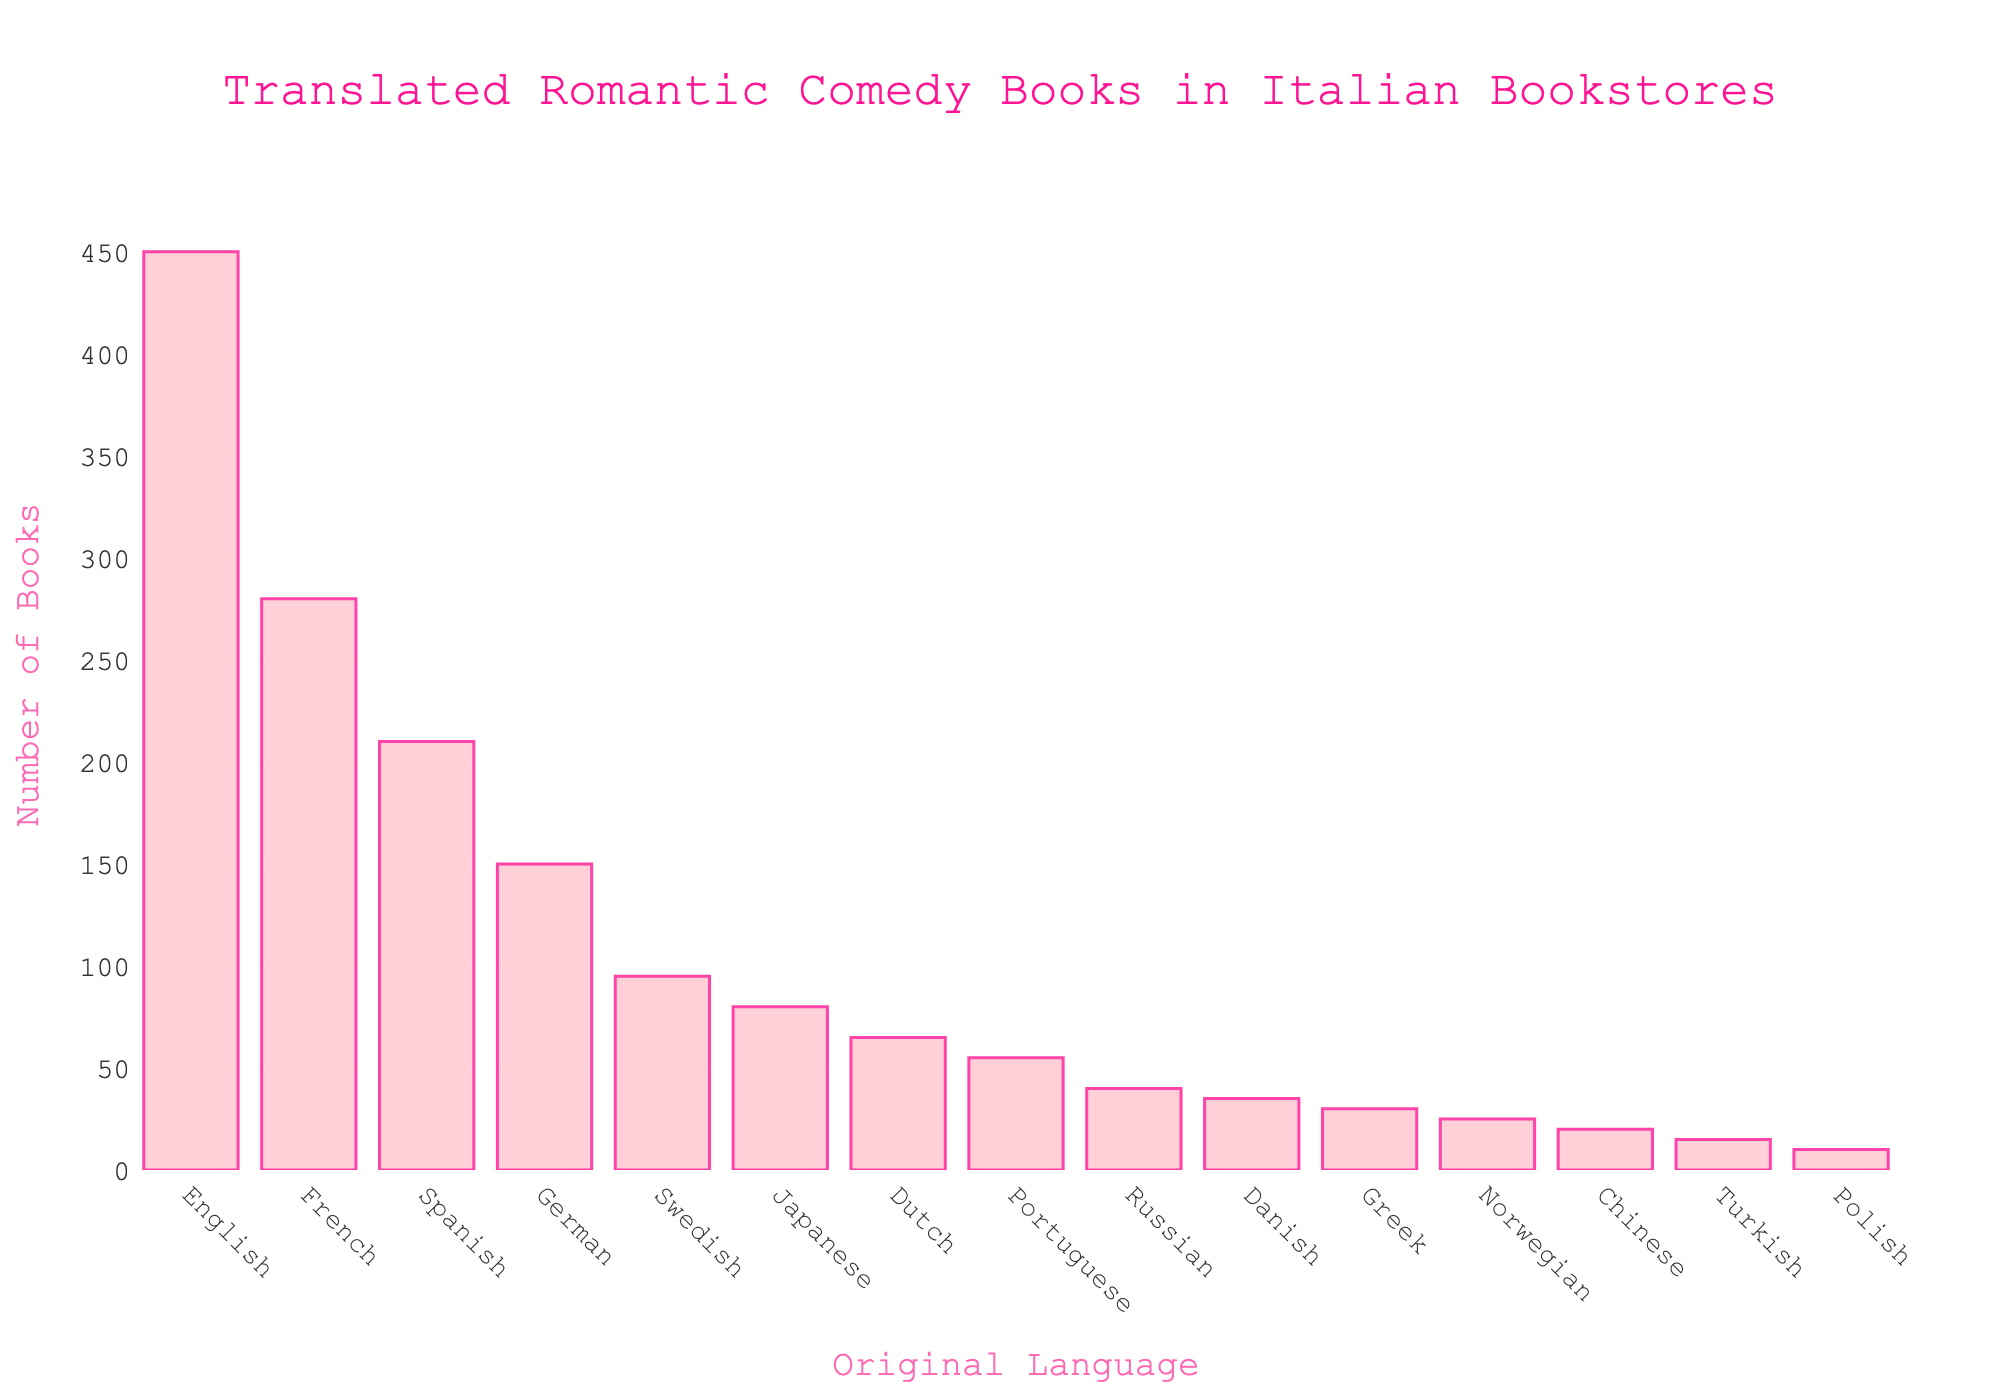What language has the most translated romantic comedy books? Observe the tallest bar in the chart, which represents the language with the highest number of translated romantic comedy books. The tallest bar corresponds to English, with 450 books.
Answer: English What is the combined number of translated romantic comedy books from French and Spanish? Identify the bars for French and Spanish. The number of books translated from French is 280, and from Spanish is 210. Adding these together: 280 + 210 = 490.
Answer: 490 How many more translated romantic comedy books are there from English than from German? Find the number of books for English (450) and German (150). Subtract the German count from the English count: 450 - 150 = 300.
Answer: 300 Which language has fewer translated books, Japanese or Dutch? Compare the bars for Japanese and Dutch. Japanese has 80 translated books, and Dutch has 65 translated books. Since 65 is less than 80, Dutch has fewer translated books.
Answer: Dutch What is the total number of translated romantic comedy books from all listed languages? Sum the number of translated books from all the languages listed: 450 + 280 + 210 + 150 + 95 + 80 + 65 + 55 + 40 + 35 + 30 + 25 + 20 + 15 + 10 = 1560.
Answer: 1560 Which language bar is the shortest in the chart? Observe the shortest bar in the chart, which represents the language with the least number of translated romantic comedy books. The shortest bar corresponds to Polish, with 10 books.
Answer: Polish What is the difference between the number of translated books from Swedish and Danish? Identify the number of translated books for Swedish (95) and Danish (35). Subtract the Danish count from the Swedish count: 95 - 35 = 60.
Answer: 60 Which two languages have the closest number of translated romantic comedy books? Look for bars that have similar heights. Japanese and Dutch bars are very close, with Japanese having 80 books and Dutch having 65 books. The difference is 80 - 65 = 15.
Answer: Japanese and Dutch If you combine the total number of translated books from the three languages with the least number of translations, what is the total? Identify the languages with the least translations: Turkish (15), Polish (10), and Chinese (20). Sum these numbers: 15 + 10 + 20 = 45.
Answer: 45 Between Russian and Portuguese, which language has more translated romantic comedy books and by how many? Compare the bars for Russian and Portuguese. Russian has 40 translated books and Portuguese has 55 translated books. Portuguese has more translated books by: 55 - 40 = 15.
Answer: Portuguese by 15 